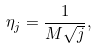<formula> <loc_0><loc_0><loc_500><loc_500>\eta _ { j } = \frac { 1 } { M \sqrt { j } } ,</formula> 